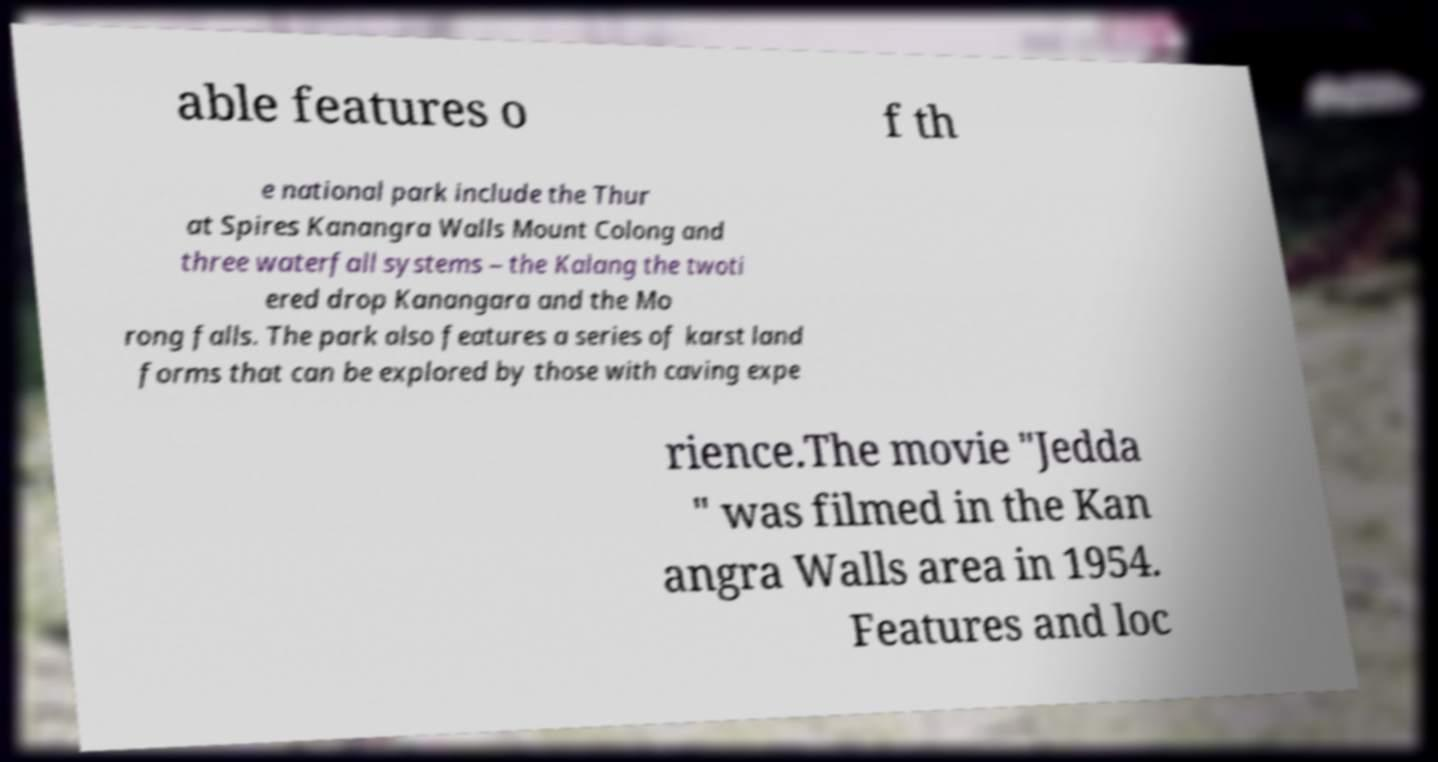For documentation purposes, I need the text within this image transcribed. Could you provide that? able features o f th e national park include the Thur at Spires Kanangra Walls Mount Colong and three waterfall systems – the Kalang the twoti ered drop Kanangara and the Mo rong falls. The park also features a series of karst land forms that can be explored by those with caving expe rience.The movie "Jedda " was filmed in the Kan angra Walls area in 1954. Features and loc 